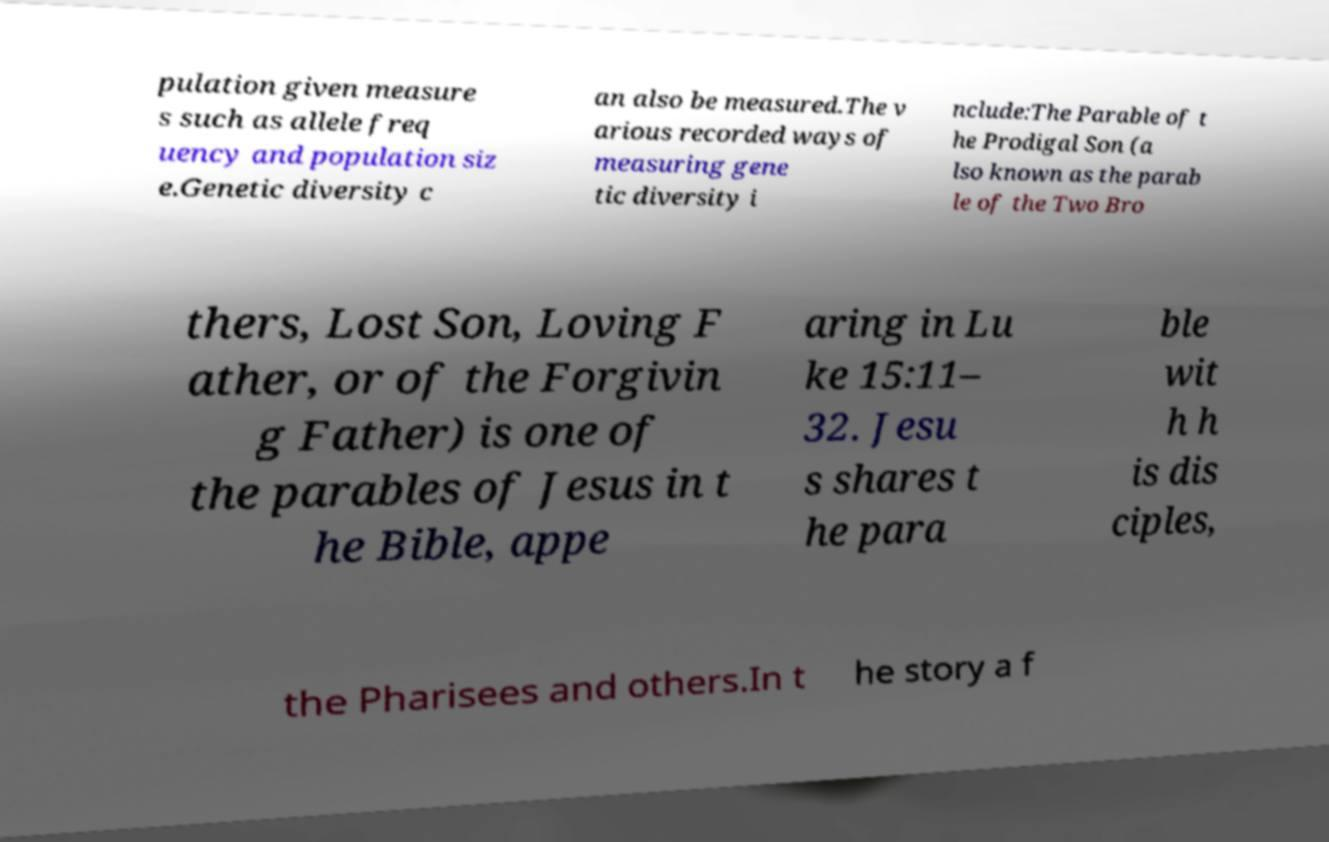Could you assist in decoding the text presented in this image and type it out clearly? pulation given measure s such as allele freq uency and population siz e.Genetic diversity c an also be measured.The v arious recorded ways of measuring gene tic diversity i nclude:The Parable of t he Prodigal Son (a lso known as the parab le of the Two Bro thers, Lost Son, Loving F ather, or of the Forgivin g Father) is one of the parables of Jesus in t he Bible, appe aring in Lu ke 15:11– 32. Jesu s shares t he para ble wit h h is dis ciples, the Pharisees and others.In t he story a f 